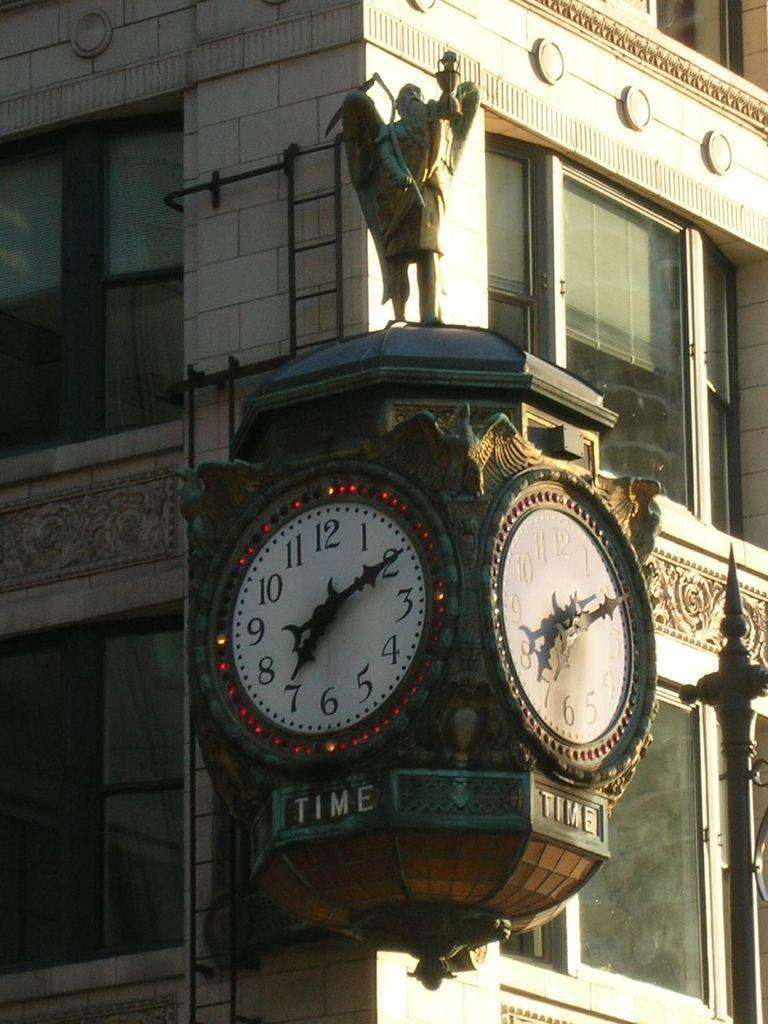<image>
Describe the image concisely. clocks on corner of building set at 7:10 and word time under each clock 